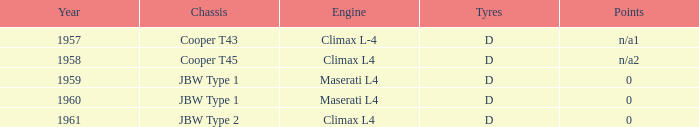What engine was in the year of 1961? Climax L4. 